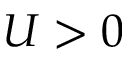Convert formula to latex. <formula><loc_0><loc_0><loc_500><loc_500>U > 0</formula> 